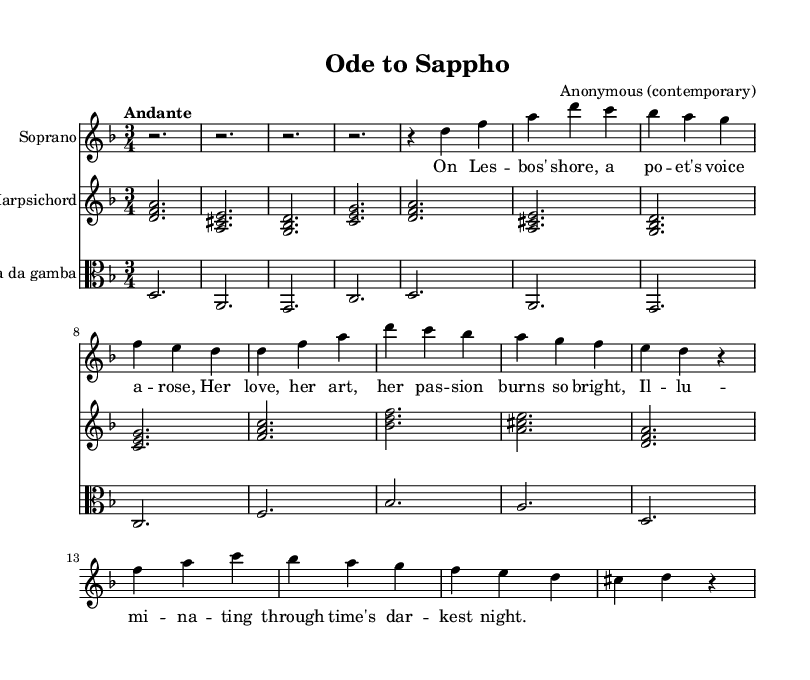What is the key signature of this music? The key signature is D minor, which has one flat. This can be confirmed by looking at the beginning of the staff where the key signature is indicated.
Answer: D minor What is the time signature of this music? The time signature is 3/4, which means there are three beats in each measure and a quarter note receives one beat. This is indicated at the beginning of the staff.
Answer: 3/4 What tempo marking is indicated for this piece? The piece is marked "Andante," which describes a moderately slow tempo. This marking appears near the beginning of the score.
Answer: Andante Which instruments are featured in this composition? The composition features Soprano, Harpsichord, and Viola da Gamba. These can be identified by their respective labels at the beginning of each staff in the score.
Answer: Soprano, Harpsichord, Viola da Gamba How many measures are in the Aria section? The Aria section consists of 8 measures. By counting the measures visually in the score, starting from the beginning of the Aria, we can determine the total.
Answer: 8 measures What type of musical form is used in this cantata? The cantata is structured with a Prelude, Recitative, and Aria, indicating a typical Baroque form focused on narrative and expressive content. Observing the arrangement of sections helps identify this form.
Answer: Prelude, Recitative, Aria 